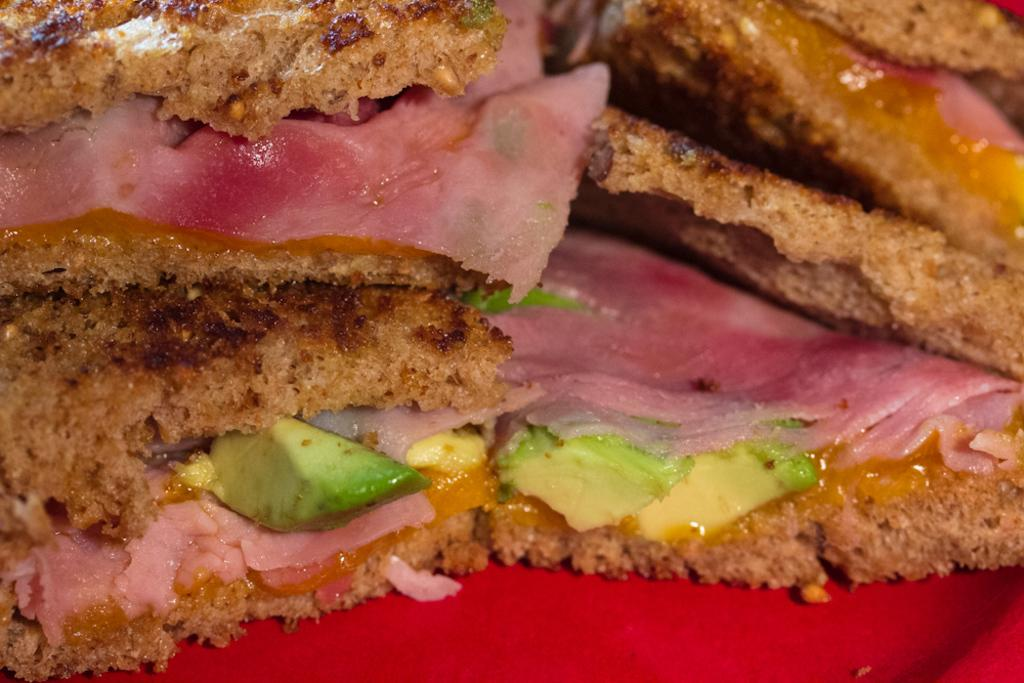What can be seen in the image? There is food visible in the image. What type of wine is being served during the holiday celebration in the image? There is no wine, holiday celebration, or any other context provided in the image; it only shows food. 